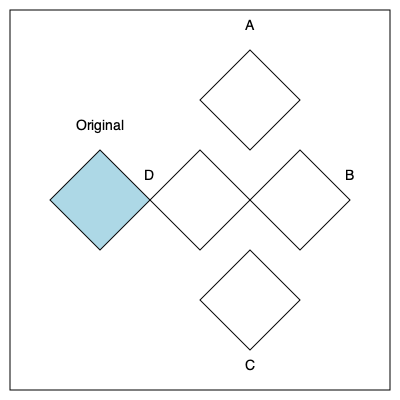As an experienced script developer, you're designing a function to rotate 2D shapes. Given the original shape on the left, which of the rotated shapes (A, B, C, or D) represents a 90-degree clockwise rotation of the original? To solve this problem, let's follow these steps:

1. Understand the original shape:
   - It's a kite-like quadrilateral with one axis of symmetry.
   - The top angle is more acute than the bottom angle.

2. Visualize a 90-degree clockwise rotation:
   - The shape should rotate to the right.
   - What was previously the top will now face right.
   - What was previously the right will now face down.

3. Analyze each option:
   - A: This is a 90-degree counterclockwise rotation.
   - B: This is a 180-degree rotation.
   - C: This is the correct 90-degree clockwise rotation.
     * The acute angle now points to the right.
     * The longer sides are now horizontal.
     * The overall orientation matches a 90-degree clockwise turn.
   - D: This is not rotated; it's a translation to the right.

4. Confirm the answer:
   - Option C correctly represents a 90-degree clockwise rotation of the original shape.

In programming terms, this rotation would be equivalent to applying a transformation matrix:

$$ \begin{bmatrix} \cos(90°) & -\sin(90°) \\ \sin(90°) & \cos(90°) \end{bmatrix} = \begin{bmatrix} 0 & -1 \\ 1 & 0 \end{bmatrix} $$

to each point of the original shape.
Answer: C 